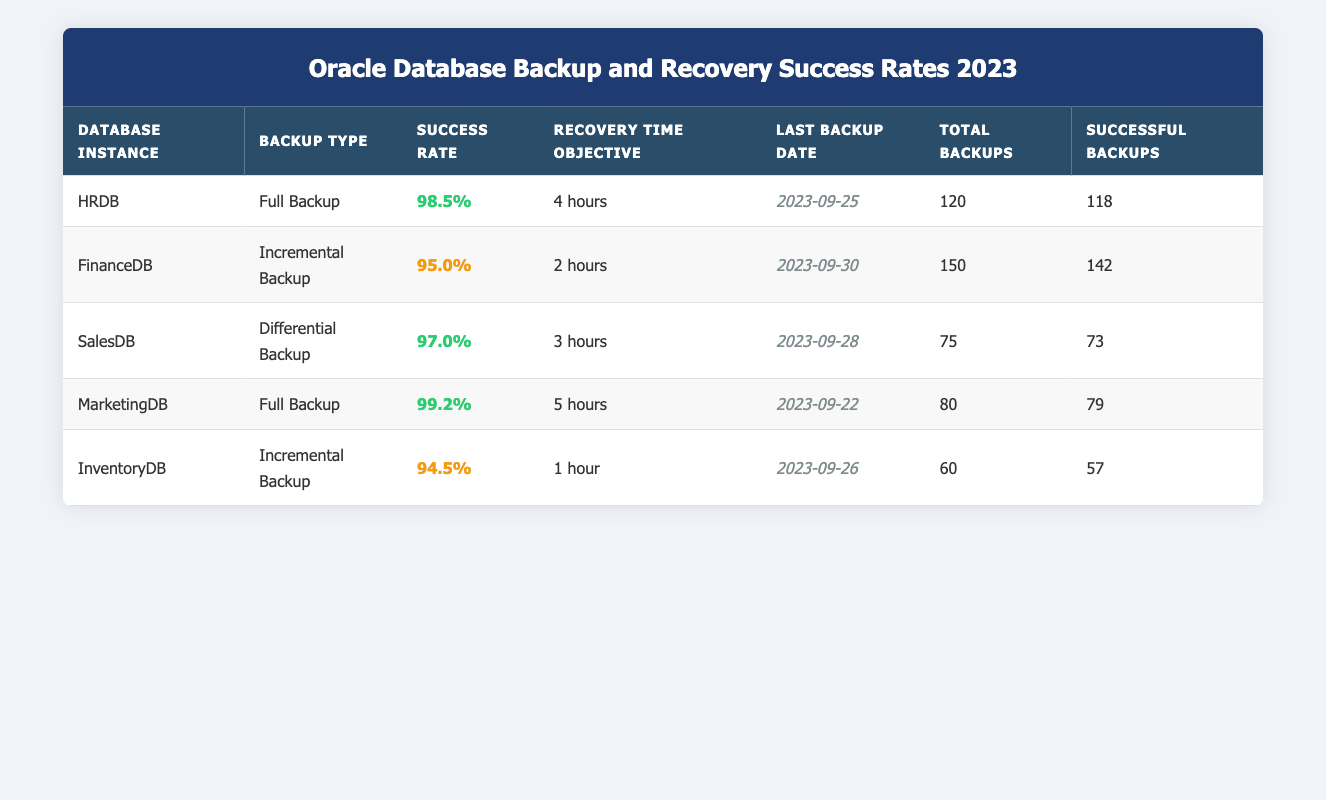What is the success rate of the MarketingDB? The MarketingDB has a success rate of 99.2% listed in the table under the Success Rate column.
Answer: 99.2% How many total backups were successfully completed for the FinanceDB? The FinanceDB shows 142 successful backups in the Successful Backups column.
Answer: 142 Which database has the highest success rate among the backups listed? By comparing the success rates of all databases, MarketingDB has the highest success rate at 99.2%.
Answer: MarketingDB What is the average success rate of all databases combined? To calculate the average, sum the success rates: (98.5 + 95.0 + 97.0 + 99.2 + 94.5) = 484.2. Then, divide by the number of databases: 484.2 / 5 = 96.84.
Answer: 96.84% Is the last backup date of the InventoryDB more recent than that of the SalesDB? The last backup date for InventoryDB is 2023-09-26 and for SalesDB is 2023-09-28. Since 2023-09-26 is earlier than 2023-09-28, the statement is false.
Answer: No What is the difference in the number of successful backups between HRDB and InventoryDB? HRDB has 118 successful backups and InventoryDB has 57. The difference is 118 - 57 = 61.
Answer: 61 Does the database SalesDB have a success rate that is above 96%? The SalesDB success rate is 97.0%, which is greater than 96%, so the statement is true.
Answer: Yes What is the recovery time objective for the database instance with the lowest success rate? The database with the lowest success rate is InventoryDB, which has a recovery time objective of 1 hour, as shown in the Recovery Time Objective column.
Answer: 1 hour How many total backups were performed for all databases combined? Summing the total backups for all databases: 120 (HRDB) + 150 (FinanceDB) + 75 (SalesDB) + 80 (MarketingDB) + 60 (InventoryDB) = 485.
Answer: 485 What percentage of successful backups does the SalesDB represent out of its total backups? For SalesDB, the percentage of successful backups is calculated as (73 / 75) * 100 = 97.33%.
Answer: 97.33% 